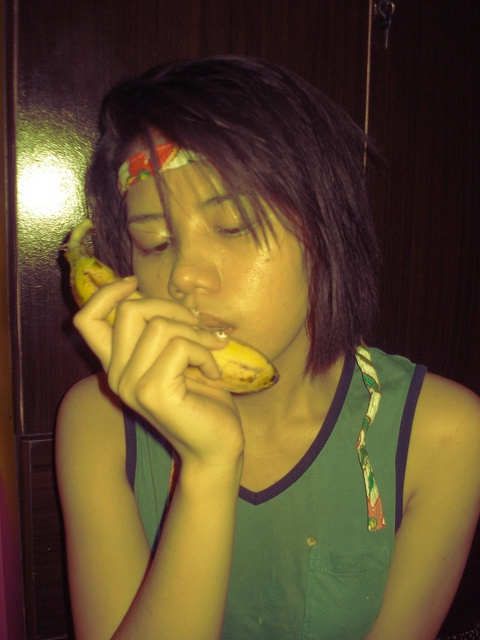Describe the objects in this image and their specific colors. I can see people in black, olive, and darkgreen tones and banana in black, olive, orange, and gold tones in this image. 